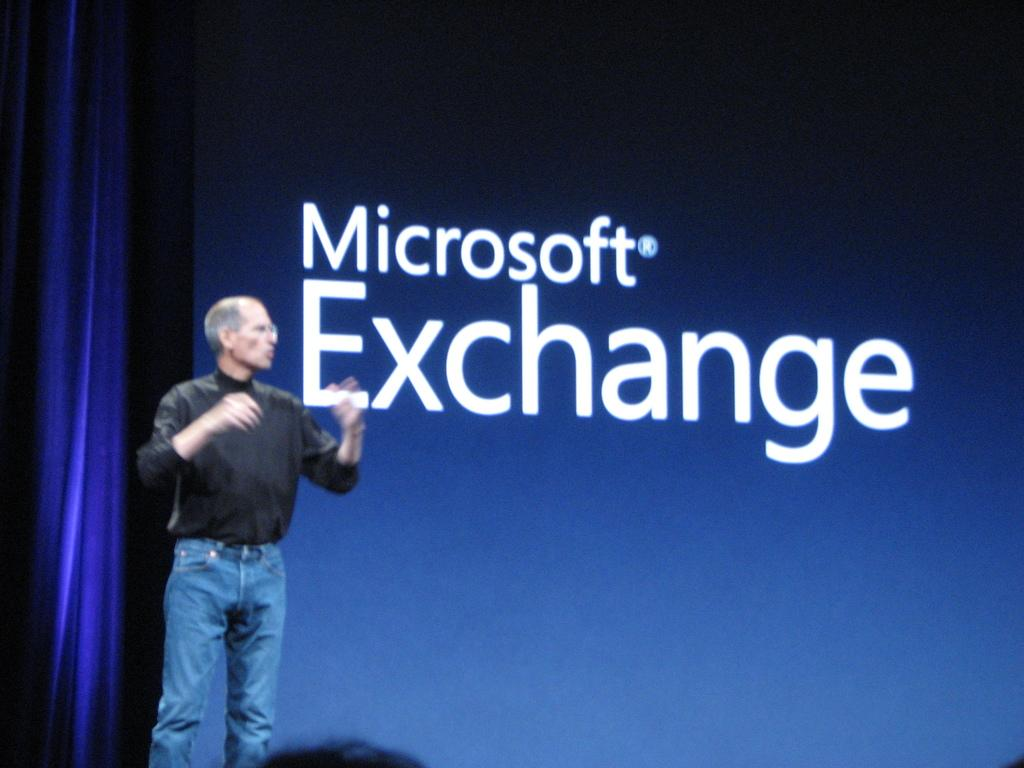What is the main subject of the image? There is a person standing on the stage. What can be seen in the background of the image? There is a curtain and a board in the background of the image. How many eggs are on the board in the image? There are no eggs visible on the board in the image. What type of cakes are being prepared on the stage? There is no indication of any cakes or cake preparation in the image. 